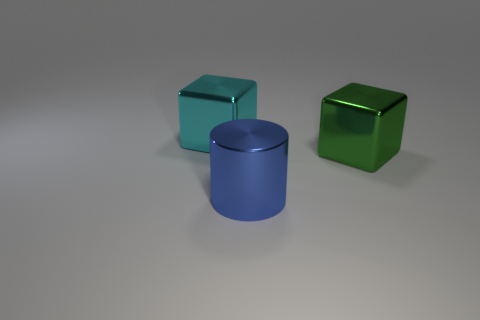There is a cube right of the blue cylinder; is it the same color as the big metallic cube that is left of the big blue cylinder?
Provide a short and direct response. No. What color is the other big thing that is the same shape as the cyan metallic thing?
Make the answer very short. Green. Is there anything else that has the same shape as the blue object?
Provide a succinct answer. No. There is a shiny thing that is right of the cylinder; does it have the same shape as the shiny thing that is to the left of the blue metal cylinder?
Make the answer very short. Yes. Are there more metallic objects than big cyan things?
Provide a succinct answer. Yes. What is the big green block made of?
Offer a terse response. Metal. Are there more green metal things on the right side of the large cylinder than red metal things?
Your response must be concise. Yes. What number of blue things are right of the block that is in front of the metal thing behind the big green metal cube?
Offer a terse response. 0. There is a big object that is both behind the large blue cylinder and in front of the big cyan metallic block; what is its material?
Offer a terse response. Metal. The large metallic cylinder is what color?
Offer a terse response. Blue. 